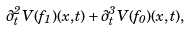Convert formula to latex. <formula><loc_0><loc_0><loc_500><loc_500>\partial ^ { 2 } _ { t } { V } ( { f } _ { 1 } ) ( x , t ) + \partial ^ { 3 } _ { t } { V } ( { f } _ { 0 } ) ( x , t ) ,</formula> 